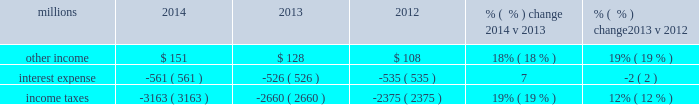Related expenses incurred by our logistics subsidiaries for external transportation and increased crew transportation and lodging due to volumes and a slower network .
In addition , higher consulting fees and higher contract expenses ( including equipment maintenance ) increased costs compared to 2013 .
Locomotive and freight car material expenses increased in 2014 compared to 2013 due to additional volumes , including the impact of activating stored equipment to address operational issues caused by demand and a slower network .
Expenses for purchased services increased 10% ( 10 % ) in 2013 compared to 2012 due to logistics management fees , an increase in locomotive overhauls and repairs on jointly owned property .
Depreciation 2013 the majority of depreciation relates to road property , including rail , ties , ballast , and other track material .
Depreciation was up 7% ( 7 % ) compared to 2013 .
A higher depreciable asset base , reflecting higher ongoing capital spending drove the increase .
Depreciation was up 1% ( 1 % ) in 2013 compared to 2012 .
Recent depreciation studies allowed us to use longer estimated service lives for certain equipment , which partially offset the impact of a higher depreciable asset base resulting from larger capital spending in recent years .
Equipment and other rents 2013 equipment and other rents expense primarily includes rental expense that the railroad pays for freight cars owned by other railroads or private companies ; freight car , intermodal , and locomotive leases ; and office and other rent expenses .
Higher intermodal volumes and longer cycle times increased short-term freight car rental expense in 2014 compared to 2013 .
Lower equipment leases essentially offset the higher freight car rental expense , as we exercised purchase options on some of our leased equipment .
Additional container costs resulting from the logistics management arrangement , and increased automotive shipments , partially offset by lower cycle times drove a $ 51 million increase in our short-term freight car rental expense in 2013 versus 2012 .
Conversely , lower locomotive and freight car lease expenses partially offset the higher freight car rental expense .
Other 2013 other expenses include state and local taxes , freight , equipment and property damage , utilities , insurance , personal injury , environmental , employee travel , telephone and cellular , computer software , bad debt , and other general expenses .
Higher property taxes , personal injury expense and utilities costs partially offset by lower environmental expense and costs associated with damaged freight drove the increase in other costs in 2014 compared to 2013 .
Higher property taxes and costs associated with damaged freight and property increased other costs in 2013 compared to 2012 .
Continued improvement in our safety performance and lower estimated liability for personal injury , which reduced our personal injury expense year-over-year , partially offset increases in other costs .
Non-operating items millions 2014 2013 2012 % (  % ) change 2014 v 2013 % (  % ) change 2013 v 2012 .
Other income 2013 other income increased in 2014 versus 2013 due to higher gains from real estate sales and a sale of a permanent easement .
These gains were partially offset by higher environmental costs on non-operating property in 2014 and lower lease income due to the $ 17 million settlement of a land lease contract in 2013 .
Other income increased in 2013 versus 2012 due to higher gains from real estate sales and increased lease income , including the favorable impact from the $ 17 million settlement of a land lease contract .
These increases were partially offset by interest received from a tax refund in 2012. .
Assuming an average interest rate of 7% ( 7 % ) , what is the implied composite debt level for 2014 , in millions? 
Computations: (561 / 7%)
Answer: 8014.28571. 